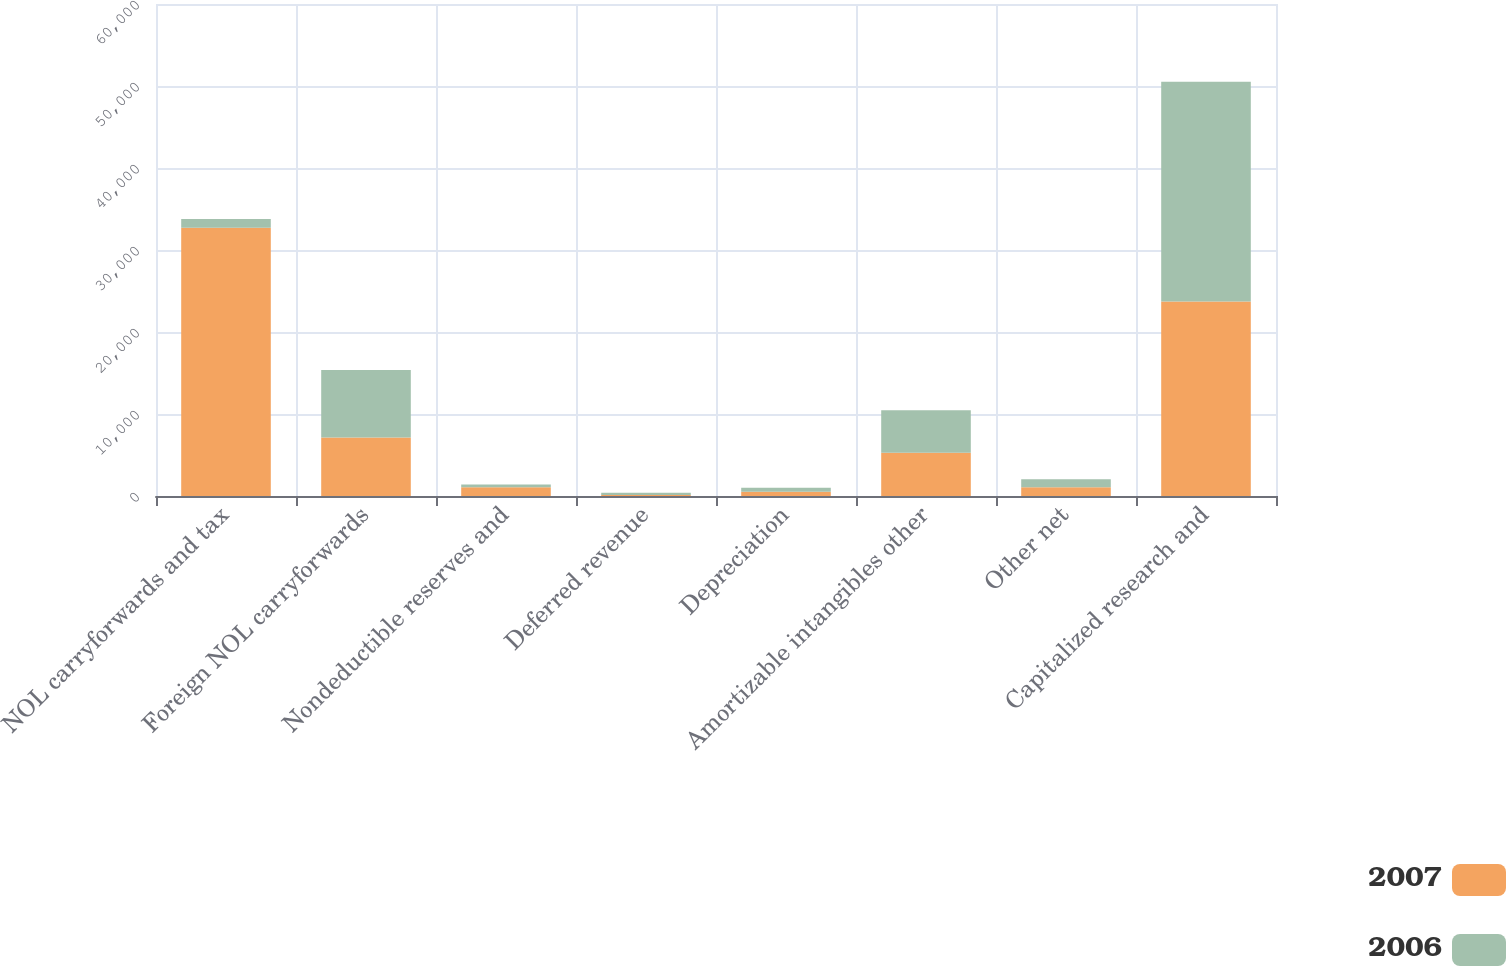<chart> <loc_0><loc_0><loc_500><loc_500><stacked_bar_chart><ecel><fcel>NOL carryforwards and tax<fcel>Foreign NOL carryforwards<fcel>Nondeductible reserves and<fcel>Deferred revenue<fcel>Depreciation<fcel>Amortizable intangibles other<fcel>Other net<fcel>Capitalized research and<nl><fcel>2007<fcel>32700<fcel>7119<fcel>1070<fcel>132<fcel>505<fcel>5284<fcel>1079<fcel>23721<nl><fcel>2006<fcel>1079<fcel>8237<fcel>338<fcel>263<fcel>489<fcel>5180<fcel>959<fcel>26801<nl></chart> 